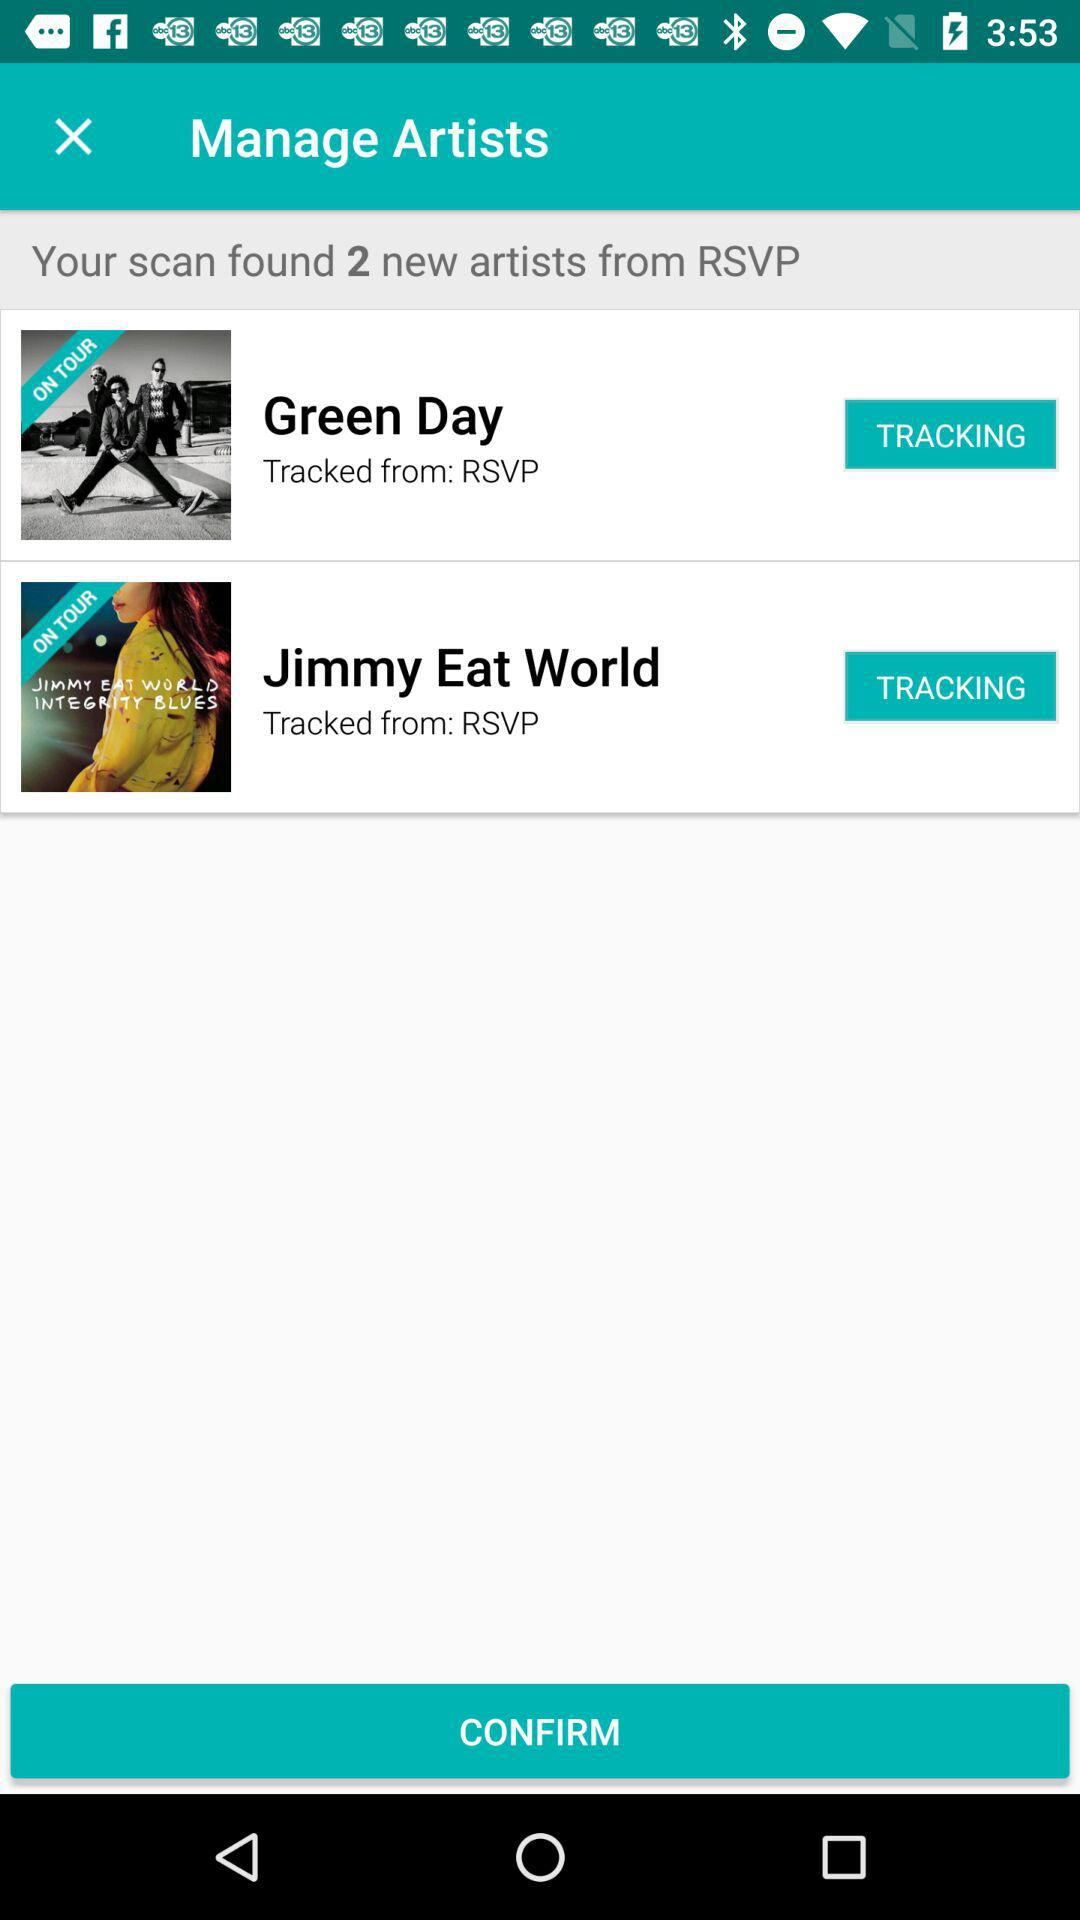What is the total number of artists found through RSVP? The total number of artists found through RSVP is 2. 